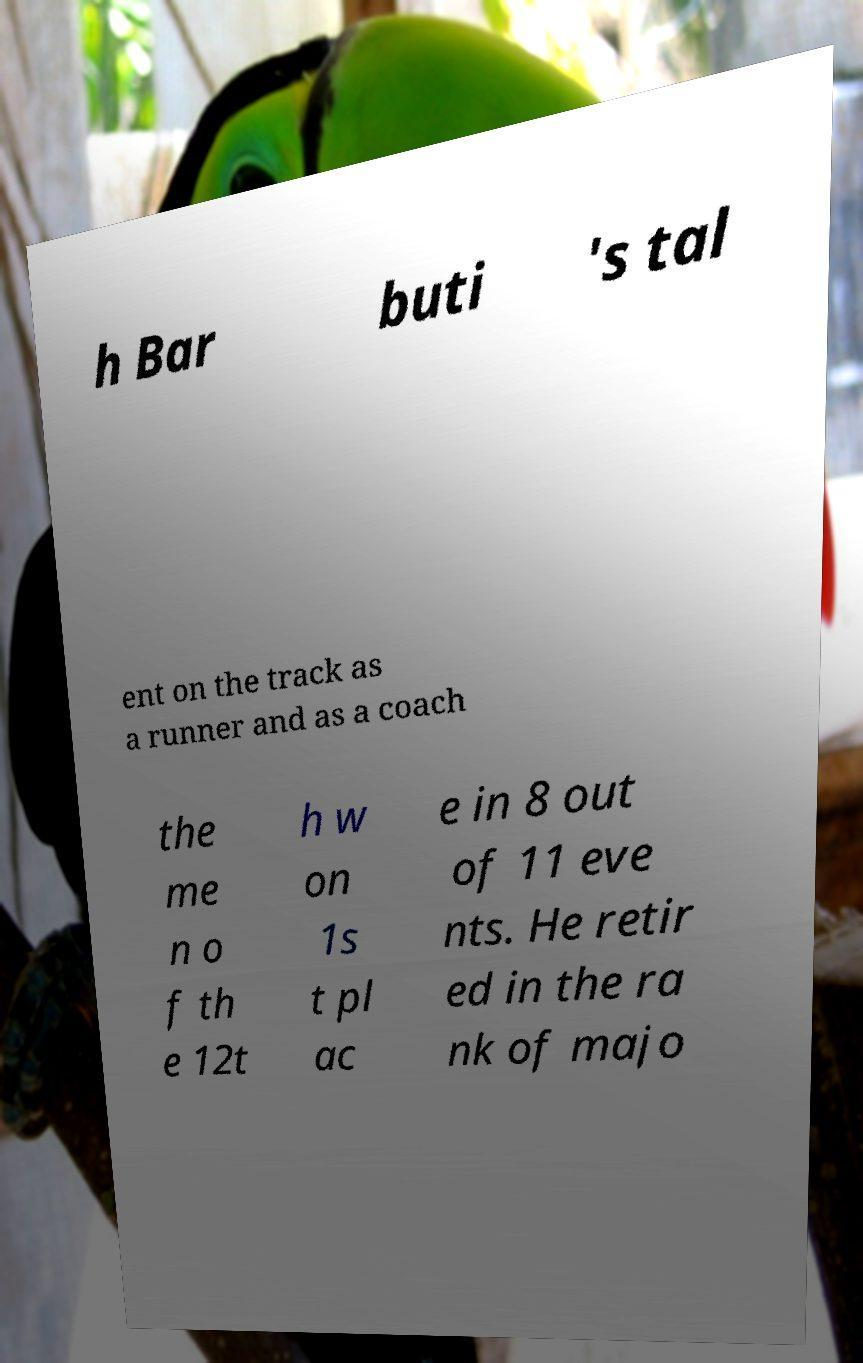I need the written content from this picture converted into text. Can you do that? h Bar buti 's tal ent on the track as a runner and as a coach the me n o f th e 12t h w on 1s t pl ac e in 8 out of 11 eve nts. He retir ed in the ra nk of majo 